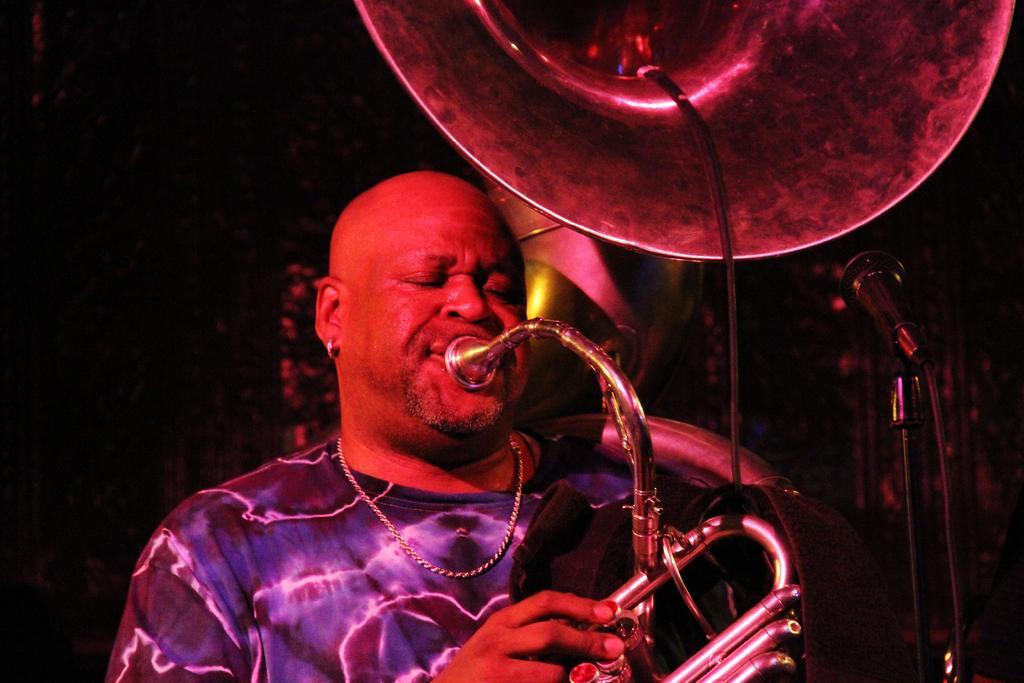Can you describe this image briefly? In this image I can see a man is playing a musical instrument. Beside him there is a mike stand. 